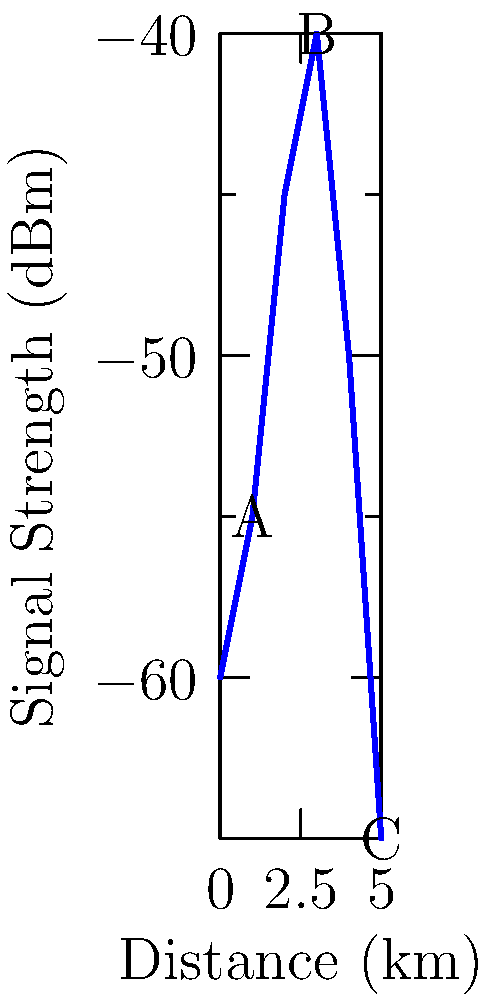The graph shows the signal strength of a radio tracking collar on an animal in a wildlife preserve as it moves away from the receiver. At which point (A, B, or C) is the animal likely closest to a geographical barrier that could be interfering with the signal? To answer this question, we need to analyze the signal strength pattern:

1. In an ideal scenario, signal strength decreases steadily with distance due to signal attenuation.

2. Point A (1 km, -55 dBm): The signal is decreasing as expected from the starting point.

3. Point B (3 km, -40 dBm): There's an unexpected increase in signal strength. This is contrary to the normal pattern and suggests signal reflection or channeling.

4. Point C (5 km, -65 dBm): The signal has dropped significantly, returning to the expected pattern of decreasing strength with distance.

5. The anomaly at Point B, where the signal strength increases despite increased distance, is likely due to a geographical feature reflecting or channeling the signal.

6. Such reflection or channeling often occurs when there's a barrier like a cliff face, large rock formation, or dense forest edge.

Therefore, the animal is likely closest to a geographical barrier at Point B, where the signal strength unexpectedly increases.
Answer: B 